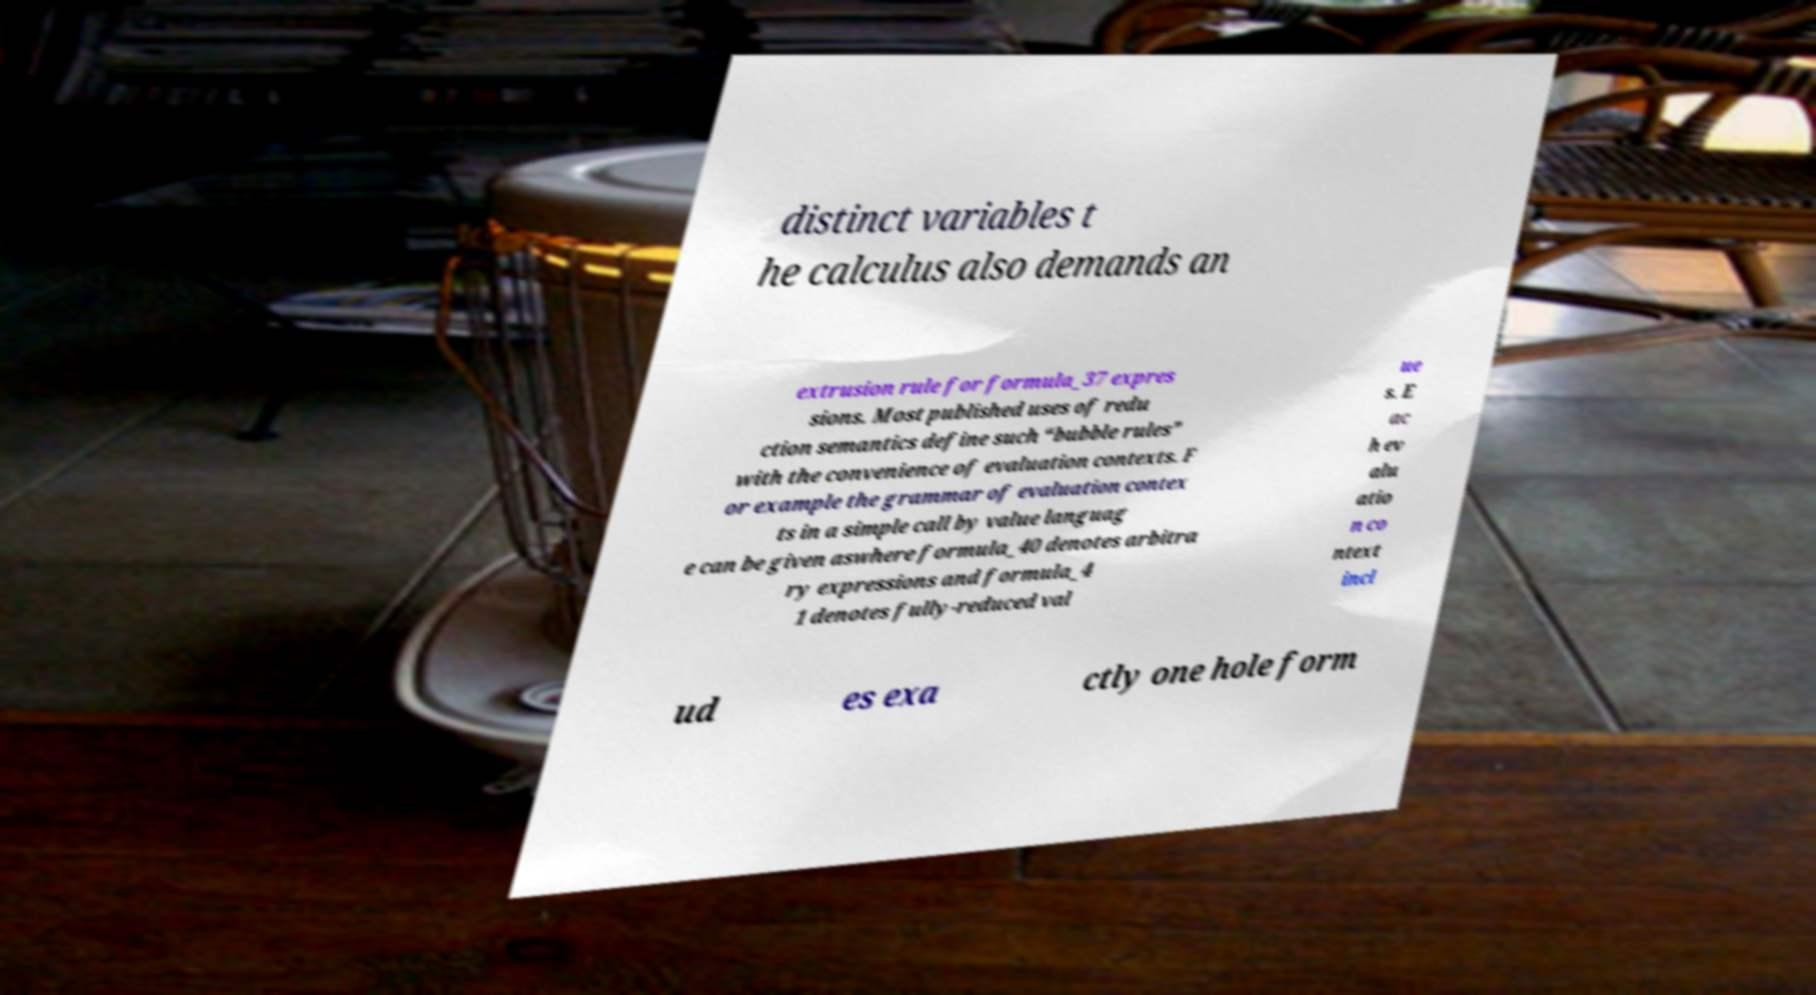Could you assist in decoding the text presented in this image and type it out clearly? distinct variables t he calculus also demands an extrusion rule for formula_37 expres sions. Most published uses of redu ction semantics define such “bubble rules” with the convenience of evaluation contexts. F or example the grammar of evaluation contex ts in a simple call by value languag e can be given aswhere formula_40 denotes arbitra ry expressions and formula_4 1 denotes fully-reduced val ue s. E ac h ev alu atio n co ntext incl ud es exa ctly one hole form 